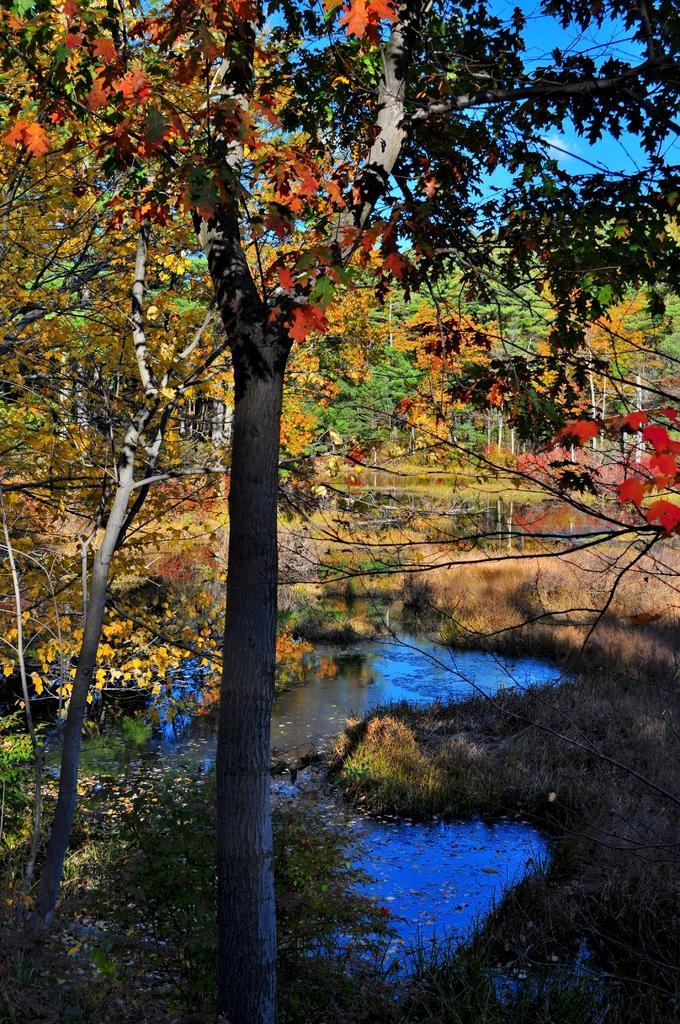Describe this image in one or two sentences. In this image in the front there are trees. In the center there is water. In the background there are trees and there's grass on the ground. 